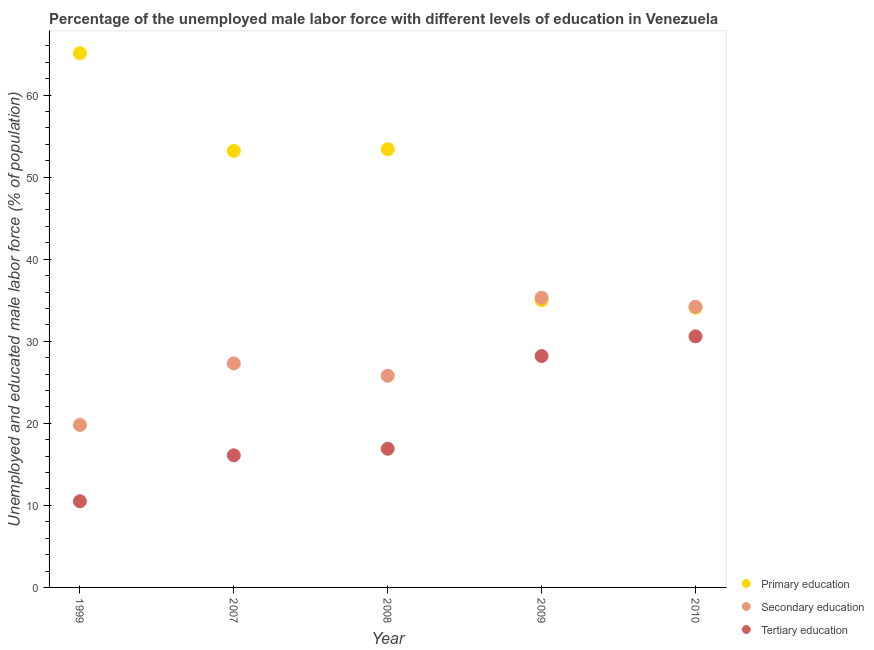Is the number of dotlines equal to the number of legend labels?
Give a very brief answer. Yes. Across all years, what is the maximum percentage of male labor force who received secondary education?
Give a very brief answer. 35.3. Across all years, what is the minimum percentage of male labor force who received tertiary education?
Ensure brevity in your answer.  10.5. In which year was the percentage of male labor force who received tertiary education maximum?
Your response must be concise. 2010. What is the total percentage of male labor force who received secondary education in the graph?
Your answer should be very brief. 142.4. What is the difference between the percentage of male labor force who received primary education in 2009 and that in 2010?
Your answer should be very brief. 0.9. What is the difference between the percentage of male labor force who received primary education in 1999 and the percentage of male labor force who received secondary education in 2008?
Your answer should be compact. 39.3. What is the average percentage of male labor force who received primary education per year?
Make the answer very short. 48.16. In the year 2008, what is the difference between the percentage of male labor force who received tertiary education and percentage of male labor force who received primary education?
Ensure brevity in your answer.  -36.5. What is the ratio of the percentage of male labor force who received secondary education in 2007 to that in 2009?
Give a very brief answer. 0.77. What is the difference between the highest and the second highest percentage of male labor force who received tertiary education?
Your response must be concise. 2.4. What is the difference between the highest and the lowest percentage of male labor force who received tertiary education?
Make the answer very short. 20.1. In how many years, is the percentage of male labor force who received primary education greater than the average percentage of male labor force who received primary education taken over all years?
Make the answer very short. 3. Is the sum of the percentage of male labor force who received secondary education in 2008 and 2009 greater than the maximum percentage of male labor force who received tertiary education across all years?
Provide a short and direct response. Yes. Does the percentage of male labor force who received secondary education monotonically increase over the years?
Offer a very short reply. No. What is the difference between two consecutive major ticks on the Y-axis?
Give a very brief answer. 10. How many legend labels are there?
Your answer should be very brief. 3. How are the legend labels stacked?
Provide a succinct answer. Vertical. What is the title of the graph?
Make the answer very short. Percentage of the unemployed male labor force with different levels of education in Venezuela. Does "Infant(male)" appear as one of the legend labels in the graph?
Offer a very short reply. No. What is the label or title of the X-axis?
Make the answer very short. Year. What is the label or title of the Y-axis?
Provide a short and direct response. Unemployed and educated male labor force (% of population). What is the Unemployed and educated male labor force (% of population) of Primary education in 1999?
Your response must be concise. 65.1. What is the Unemployed and educated male labor force (% of population) of Secondary education in 1999?
Give a very brief answer. 19.8. What is the Unemployed and educated male labor force (% of population) of Tertiary education in 1999?
Your answer should be compact. 10.5. What is the Unemployed and educated male labor force (% of population) of Primary education in 2007?
Provide a succinct answer. 53.2. What is the Unemployed and educated male labor force (% of population) in Secondary education in 2007?
Your answer should be compact. 27.3. What is the Unemployed and educated male labor force (% of population) of Tertiary education in 2007?
Make the answer very short. 16.1. What is the Unemployed and educated male labor force (% of population) in Primary education in 2008?
Give a very brief answer. 53.4. What is the Unemployed and educated male labor force (% of population) of Secondary education in 2008?
Your answer should be compact. 25.8. What is the Unemployed and educated male labor force (% of population) in Tertiary education in 2008?
Your response must be concise. 16.9. What is the Unemployed and educated male labor force (% of population) of Secondary education in 2009?
Give a very brief answer. 35.3. What is the Unemployed and educated male labor force (% of population) in Tertiary education in 2009?
Make the answer very short. 28.2. What is the Unemployed and educated male labor force (% of population) of Primary education in 2010?
Offer a very short reply. 34.1. What is the Unemployed and educated male labor force (% of population) in Secondary education in 2010?
Ensure brevity in your answer.  34.2. What is the Unemployed and educated male labor force (% of population) of Tertiary education in 2010?
Offer a very short reply. 30.6. Across all years, what is the maximum Unemployed and educated male labor force (% of population) of Primary education?
Provide a succinct answer. 65.1. Across all years, what is the maximum Unemployed and educated male labor force (% of population) in Secondary education?
Make the answer very short. 35.3. Across all years, what is the maximum Unemployed and educated male labor force (% of population) in Tertiary education?
Your answer should be very brief. 30.6. Across all years, what is the minimum Unemployed and educated male labor force (% of population) of Primary education?
Your answer should be very brief. 34.1. Across all years, what is the minimum Unemployed and educated male labor force (% of population) of Secondary education?
Offer a very short reply. 19.8. Across all years, what is the minimum Unemployed and educated male labor force (% of population) of Tertiary education?
Give a very brief answer. 10.5. What is the total Unemployed and educated male labor force (% of population) of Primary education in the graph?
Provide a succinct answer. 240.8. What is the total Unemployed and educated male labor force (% of population) in Secondary education in the graph?
Keep it short and to the point. 142.4. What is the total Unemployed and educated male labor force (% of population) in Tertiary education in the graph?
Your answer should be compact. 102.3. What is the difference between the Unemployed and educated male labor force (% of population) in Primary education in 1999 and that in 2007?
Provide a short and direct response. 11.9. What is the difference between the Unemployed and educated male labor force (% of population) in Tertiary education in 1999 and that in 2008?
Give a very brief answer. -6.4. What is the difference between the Unemployed and educated male labor force (% of population) in Primary education in 1999 and that in 2009?
Keep it short and to the point. 30.1. What is the difference between the Unemployed and educated male labor force (% of population) in Secondary education in 1999 and that in 2009?
Your answer should be compact. -15.5. What is the difference between the Unemployed and educated male labor force (% of population) in Tertiary education in 1999 and that in 2009?
Give a very brief answer. -17.7. What is the difference between the Unemployed and educated male labor force (% of population) in Primary education in 1999 and that in 2010?
Your answer should be compact. 31. What is the difference between the Unemployed and educated male labor force (% of population) of Secondary education in 1999 and that in 2010?
Make the answer very short. -14.4. What is the difference between the Unemployed and educated male labor force (% of population) of Tertiary education in 1999 and that in 2010?
Make the answer very short. -20.1. What is the difference between the Unemployed and educated male labor force (% of population) in Primary education in 2007 and that in 2008?
Offer a very short reply. -0.2. What is the difference between the Unemployed and educated male labor force (% of population) in Tertiary education in 2007 and that in 2008?
Provide a succinct answer. -0.8. What is the difference between the Unemployed and educated male labor force (% of population) of Tertiary education in 2007 and that in 2009?
Make the answer very short. -12.1. What is the difference between the Unemployed and educated male labor force (% of population) of Primary education in 2008 and that in 2009?
Ensure brevity in your answer.  18.4. What is the difference between the Unemployed and educated male labor force (% of population) in Secondary education in 2008 and that in 2009?
Provide a short and direct response. -9.5. What is the difference between the Unemployed and educated male labor force (% of population) of Tertiary education in 2008 and that in 2009?
Keep it short and to the point. -11.3. What is the difference between the Unemployed and educated male labor force (% of population) of Primary education in 2008 and that in 2010?
Keep it short and to the point. 19.3. What is the difference between the Unemployed and educated male labor force (% of population) of Tertiary education in 2008 and that in 2010?
Your answer should be very brief. -13.7. What is the difference between the Unemployed and educated male labor force (% of population) in Tertiary education in 2009 and that in 2010?
Your response must be concise. -2.4. What is the difference between the Unemployed and educated male labor force (% of population) of Primary education in 1999 and the Unemployed and educated male labor force (% of population) of Secondary education in 2007?
Your answer should be compact. 37.8. What is the difference between the Unemployed and educated male labor force (% of population) of Primary education in 1999 and the Unemployed and educated male labor force (% of population) of Tertiary education in 2007?
Your answer should be very brief. 49. What is the difference between the Unemployed and educated male labor force (% of population) of Primary education in 1999 and the Unemployed and educated male labor force (% of population) of Secondary education in 2008?
Your response must be concise. 39.3. What is the difference between the Unemployed and educated male labor force (% of population) in Primary education in 1999 and the Unemployed and educated male labor force (% of population) in Tertiary education in 2008?
Ensure brevity in your answer.  48.2. What is the difference between the Unemployed and educated male labor force (% of population) in Secondary education in 1999 and the Unemployed and educated male labor force (% of population) in Tertiary education in 2008?
Your answer should be very brief. 2.9. What is the difference between the Unemployed and educated male labor force (% of population) in Primary education in 1999 and the Unemployed and educated male labor force (% of population) in Secondary education in 2009?
Your response must be concise. 29.8. What is the difference between the Unemployed and educated male labor force (% of population) of Primary education in 1999 and the Unemployed and educated male labor force (% of population) of Tertiary education in 2009?
Ensure brevity in your answer.  36.9. What is the difference between the Unemployed and educated male labor force (% of population) of Primary education in 1999 and the Unemployed and educated male labor force (% of population) of Secondary education in 2010?
Offer a terse response. 30.9. What is the difference between the Unemployed and educated male labor force (% of population) in Primary education in 1999 and the Unemployed and educated male labor force (% of population) in Tertiary education in 2010?
Keep it short and to the point. 34.5. What is the difference between the Unemployed and educated male labor force (% of population) in Primary education in 2007 and the Unemployed and educated male labor force (% of population) in Secondary education in 2008?
Your response must be concise. 27.4. What is the difference between the Unemployed and educated male labor force (% of population) of Primary education in 2007 and the Unemployed and educated male labor force (% of population) of Tertiary education in 2008?
Offer a terse response. 36.3. What is the difference between the Unemployed and educated male labor force (% of population) in Primary education in 2007 and the Unemployed and educated male labor force (% of population) in Secondary education in 2009?
Ensure brevity in your answer.  17.9. What is the difference between the Unemployed and educated male labor force (% of population) in Primary education in 2007 and the Unemployed and educated male labor force (% of population) in Secondary education in 2010?
Make the answer very short. 19. What is the difference between the Unemployed and educated male labor force (% of population) of Primary education in 2007 and the Unemployed and educated male labor force (% of population) of Tertiary education in 2010?
Your answer should be very brief. 22.6. What is the difference between the Unemployed and educated male labor force (% of population) in Primary education in 2008 and the Unemployed and educated male labor force (% of population) in Tertiary education in 2009?
Provide a succinct answer. 25.2. What is the difference between the Unemployed and educated male labor force (% of population) of Primary education in 2008 and the Unemployed and educated male labor force (% of population) of Tertiary education in 2010?
Make the answer very short. 22.8. What is the difference between the Unemployed and educated male labor force (% of population) in Secondary education in 2008 and the Unemployed and educated male labor force (% of population) in Tertiary education in 2010?
Keep it short and to the point. -4.8. What is the difference between the Unemployed and educated male labor force (% of population) in Primary education in 2009 and the Unemployed and educated male labor force (% of population) in Secondary education in 2010?
Offer a terse response. 0.8. What is the difference between the Unemployed and educated male labor force (% of population) in Secondary education in 2009 and the Unemployed and educated male labor force (% of population) in Tertiary education in 2010?
Provide a succinct answer. 4.7. What is the average Unemployed and educated male labor force (% of population) of Primary education per year?
Ensure brevity in your answer.  48.16. What is the average Unemployed and educated male labor force (% of population) in Secondary education per year?
Make the answer very short. 28.48. What is the average Unemployed and educated male labor force (% of population) of Tertiary education per year?
Keep it short and to the point. 20.46. In the year 1999, what is the difference between the Unemployed and educated male labor force (% of population) of Primary education and Unemployed and educated male labor force (% of population) of Secondary education?
Provide a short and direct response. 45.3. In the year 1999, what is the difference between the Unemployed and educated male labor force (% of population) in Primary education and Unemployed and educated male labor force (% of population) in Tertiary education?
Give a very brief answer. 54.6. In the year 1999, what is the difference between the Unemployed and educated male labor force (% of population) of Secondary education and Unemployed and educated male labor force (% of population) of Tertiary education?
Ensure brevity in your answer.  9.3. In the year 2007, what is the difference between the Unemployed and educated male labor force (% of population) in Primary education and Unemployed and educated male labor force (% of population) in Secondary education?
Your response must be concise. 25.9. In the year 2007, what is the difference between the Unemployed and educated male labor force (% of population) of Primary education and Unemployed and educated male labor force (% of population) of Tertiary education?
Offer a very short reply. 37.1. In the year 2008, what is the difference between the Unemployed and educated male labor force (% of population) of Primary education and Unemployed and educated male labor force (% of population) of Secondary education?
Your answer should be compact. 27.6. In the year 2008, what is the difference between the Unemployed and educated male labor force (% of population) in Primary education and Unemployed and educated male labor force (% of population) in Tertiary education?
Your answer should be very brief. 36.5. In the year 2008, what is the difference between the Unemployed and educated male labor force (% of population) in Secondary education and Unemployed and educated male labor force (% of population) in Tertiary education?
Ensure brevity in your answer.  8.9. In the year 2009, what is the difference between the Unemployed and educated male labor force (% of population) of Secondary education and Unemployed and educated male labor force (% of population) of Tertiary education?
Provide a short and direct response. 7.1. In the year 2010, what is the difference between the Unemployed and educated male labor force (% of population) of Primary education and Unemployed and educated male labor force (% of population) of Secondary education?
Offer a very short reply. -0.1. In the year 2010, what is the difference between the Unemployed and educated male labor force (% of population) in Primary education and Unemployed and educated male labor force (% of population) in Tertiary education?
Keep it short and to the point. 3.5. What is the ratio of the Unemployed and educated male labor force (% of population) in Primary education in 1999 to that in 2007?
Make the answer very short. 1.22. What is the ratio of the Unemployed and educated male labor force (% of population) in Secondary education in 1999 to that in 2007?
Provide a succinct answer. 0.73. What is the ratio of the Unemployed and educated male labor force (% of population) of Tertiary education in 1999 to that in 2007?
Your response must be concise. 0.65. What is the ratio of the Unemployed and educated male labor force (% of population) of Primary education in 1999 to that in 2008?
Offer a very short reply. 1.22. What is the ratio of the Unemployed and educated male labor force (% of population) in Secondary education in 1999 to that in 2008?
Your response must be concise. 0.77. What is the ratio of the Unemployed and educated male labor force (% of population) in Tertiary education in 1999 to that in 2008?
Offer a very short reply. 0.62. What is the ratio of the Unemployed and educated male labor force (% of population) of Primary education in 1999 to that in 2009?
Keep it short and to the point. 1.86. What is the ratio of the Unemployed and educated male labor force (% of population) of Secondary education in 1999 to that in 2009?
Offer a very short reply. 0.56. What is the ratio of the Unemployed and educated male labor force (% of population) in Tertiary education in 1999 to that in 2009?
Provide a short and direct response. 0.37. What is the ratio of the Unemployed and educated male labor force (% of population) in Primary education in 1999 to that in 2010?
Provide a short and direct response. 1.91. What is the ratio of the Unemployed and educated male labor force (% of population) in Secondary education in 1999 to that in 2010?
Your answer should be compact. 0.58. What is the ratio of the Unemployed and educated male labor force (% of population) in Tertiary education in 1999 to that in 2010?
Give a very brief answer. 0.34. What is the ratio of the Unemployed and educated male labor force (% of population) of Primary education in 2007 to that in 2008?
Provide a succinct answer. 1. What is the ratio of the Unemployed and educated male labor force (% of population) in Secondary education in 2007 to that in 2008?
Provide a succinct answer. 1.06. What is the ratio of the Unemployed and educated male labor force (% of population) in Tertiary education in 2007 to that in 2008?
Give a very brief answer. 0.95. What is the ratio of the Unemployed and educated male labor force (% of population) in Primary education in 2007 to that in 2009?
Your response must be concise. 1.52. What is the ratio of the Unemployed and educated male labor force (% of population) in Secondary education in 2007 to that in 2009?
Offer a very short reply. 0.77. What is the ratio of the Unemployed and educated male labor force (% of population) of Tertiary education in 2007 to that in 2009?
Provide a short and direct response. 0.57. What is the ratio of the Unemployed and educated male labor force (% of population) in Primary education in 2007 to that in 2010?
Make the answer very short. 1.56. What is the ratio of the Unemployed and educated male labor force (% of population) in Secondary education in 2007 to that in 2010?
Your answer should be very brief. 0.8. What is the ratio of the Unemployed and educated male labor force (% of population) of Tertiary education in 2007 to that in 2010?
Ensure brevity in your answer.  0.53. What is the ratio of the Unemployed and educated male labor force (% of population) of Primary education in 2008 to that in 2009?
Make the answer very short. 1.53. What is the ratio of the Unemployed and educated male labor force (% of population) in Secondary education in 2008 to that in 2009?
Provide a succinct answer. 0.73. What is the ratio of the Unemployed and educated male labor force (% of population) in Tertiary education in 2008 to that in 2009?
Keep it short and to the point. 0.6. What is the ratio of the Unemployed and educated male labor force (% of population) of Primary education in 2008 to that in 2010?
Provide a succinct answer. 1.57. What is the ratio of the Unemployed and educated male labor force (% of population) of Secondary education in 2008 to that in 2010?
Give a very brief answer. 0.75. What is the ratio of the Unemployed and educated male labor force (% of population) of Tertiary education in 2008 to that in 2010?
Keep it short and to the point. 0.55. What is the ratio of the Unemployed and educated male labor force (% of population) in Primary education in 2009 to that in 2010?
Offer a terse response. 1.03. What is the ratio of the Unemployed and educated male labor force (% of population) of Secondary education in 2009 to that in 2010?
Keep it short and to the point. 1.03. What is the ratio of the Unemployed and educated male labor force (% of population) in Tertiary education in 2009 to that in 2010?
Provide a succinct answer. 0.92. What is the difference between the highest and the second highest Unemployed and educated male labor force (% of population) in Primary education?
Provide a short and direct response. 11.7. What is the difference between the highest and the second highest Unemployed and educated male labor force (% of population) of Tertiary education?
Make the answer very short. 2.4. What is the difference between the highest and the lowest Unemployed and educated male labor force (% of population) in Primary education?
Your response must be concise. 31. What is the difference between the highest and the lowest Unemployed and educated male labor force (% of population) of Tertiary education?
Your answer should be compact. 20.1. 